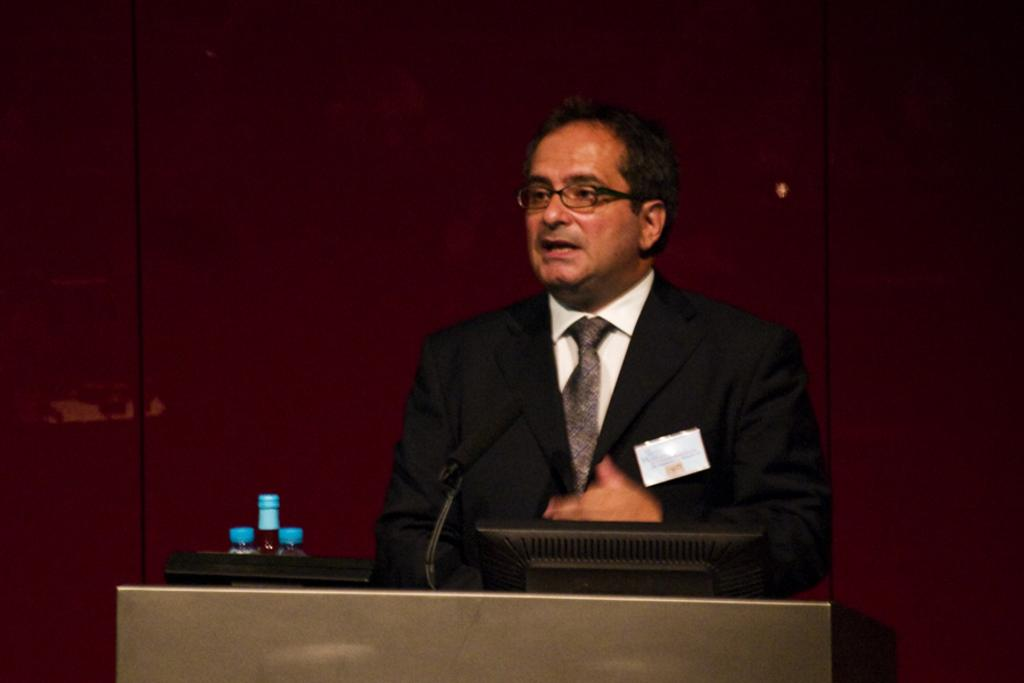Who is the main subject in the image? There is a man in the middle of the image. What is the man is standing in front of? There is a podium in front of the man. What items can be seen on the podium? There are bottles, a microphone, and a desktop on the podium. What is visible in the background of the image? There is a wall in the background of the image. What type of leaf is being used as an umbrella by the man in the image? There is no leaf or umbrella present in the image. What point is the man trying to make in the image? The image does not provide any context or information about the man's message or point. 